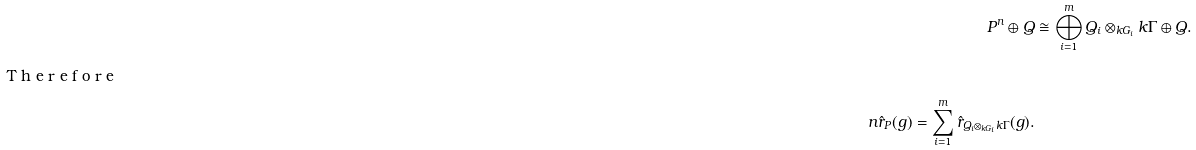<formula> <loc_0><loc_0><loc_500><loc_500>P ^ { n } \oplus Q & \cong \bigoplus _ { i = 1 } ^ { m } Q _ { i } \otimes _ { k G _ { i } } k \Gamma \oplus Q . \\ \intertext { T h e r e f o r e } n \hat { r } _ { P } ( g ) = \sum _ { i = 1 } ^ { m } \hat { r } _ { Q _ { i } \otimes _ { k G _ { i } } k \Gamma } ( g ) .</formula> 